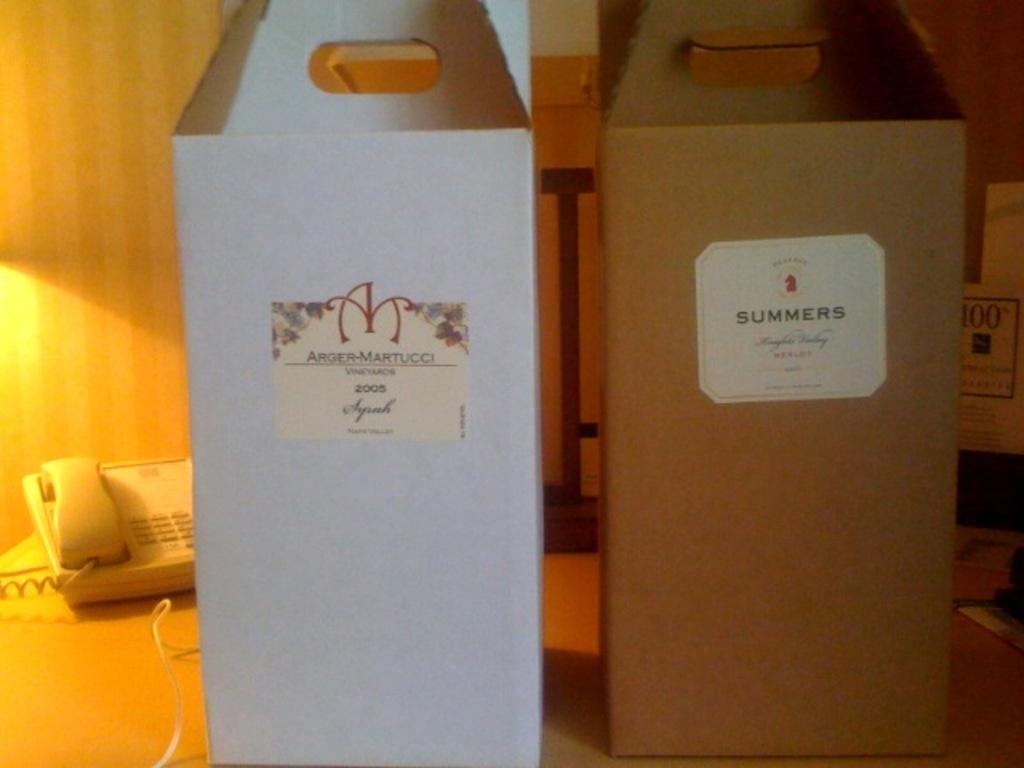What brand is the wine in the boxes?
Your response must be concise. Summers. What year was the wine on the left made?
Your response must be concise. 2005. 